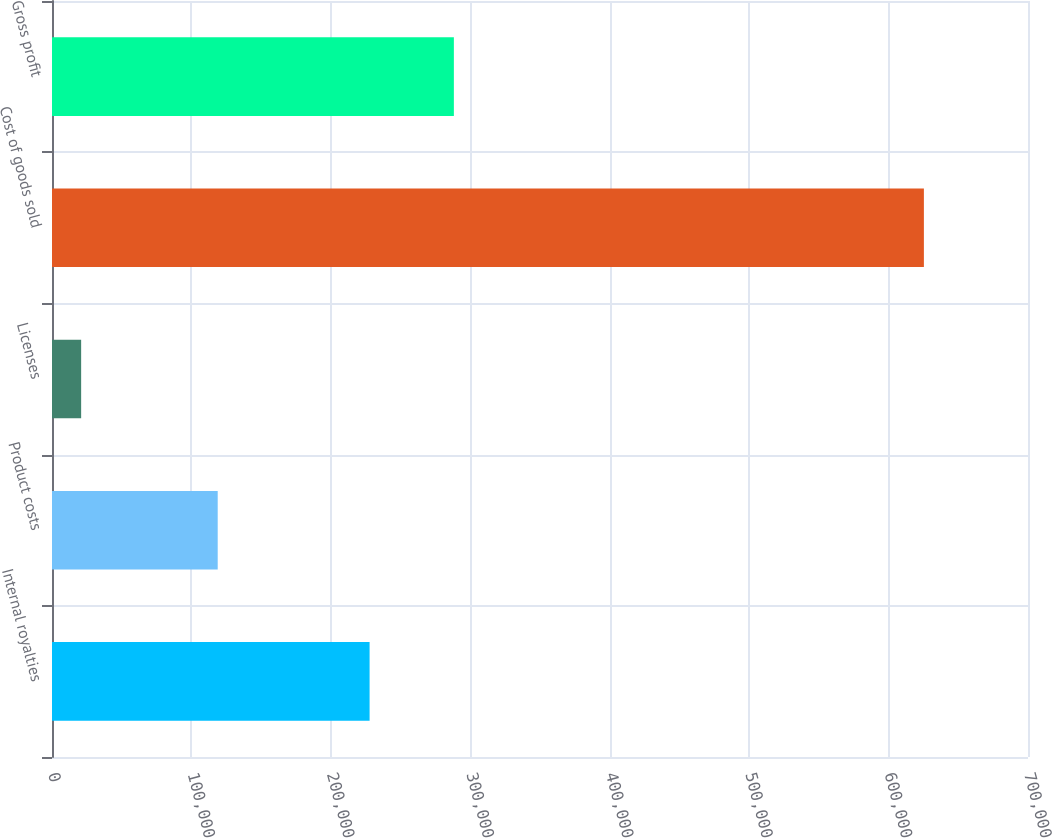Convert chart. <chart><loc_0><loc_0><loc_500><loc_500><bar_chart><fcel>Internal royalties<fcel>Product costs<fcel>Licenses<fcel>Cost of goods sold<fcel>Gross profit<nl><fcel>227784<fcel>118847<fcel>20904<fcel>625333<fcel>288227<nl></chart> 